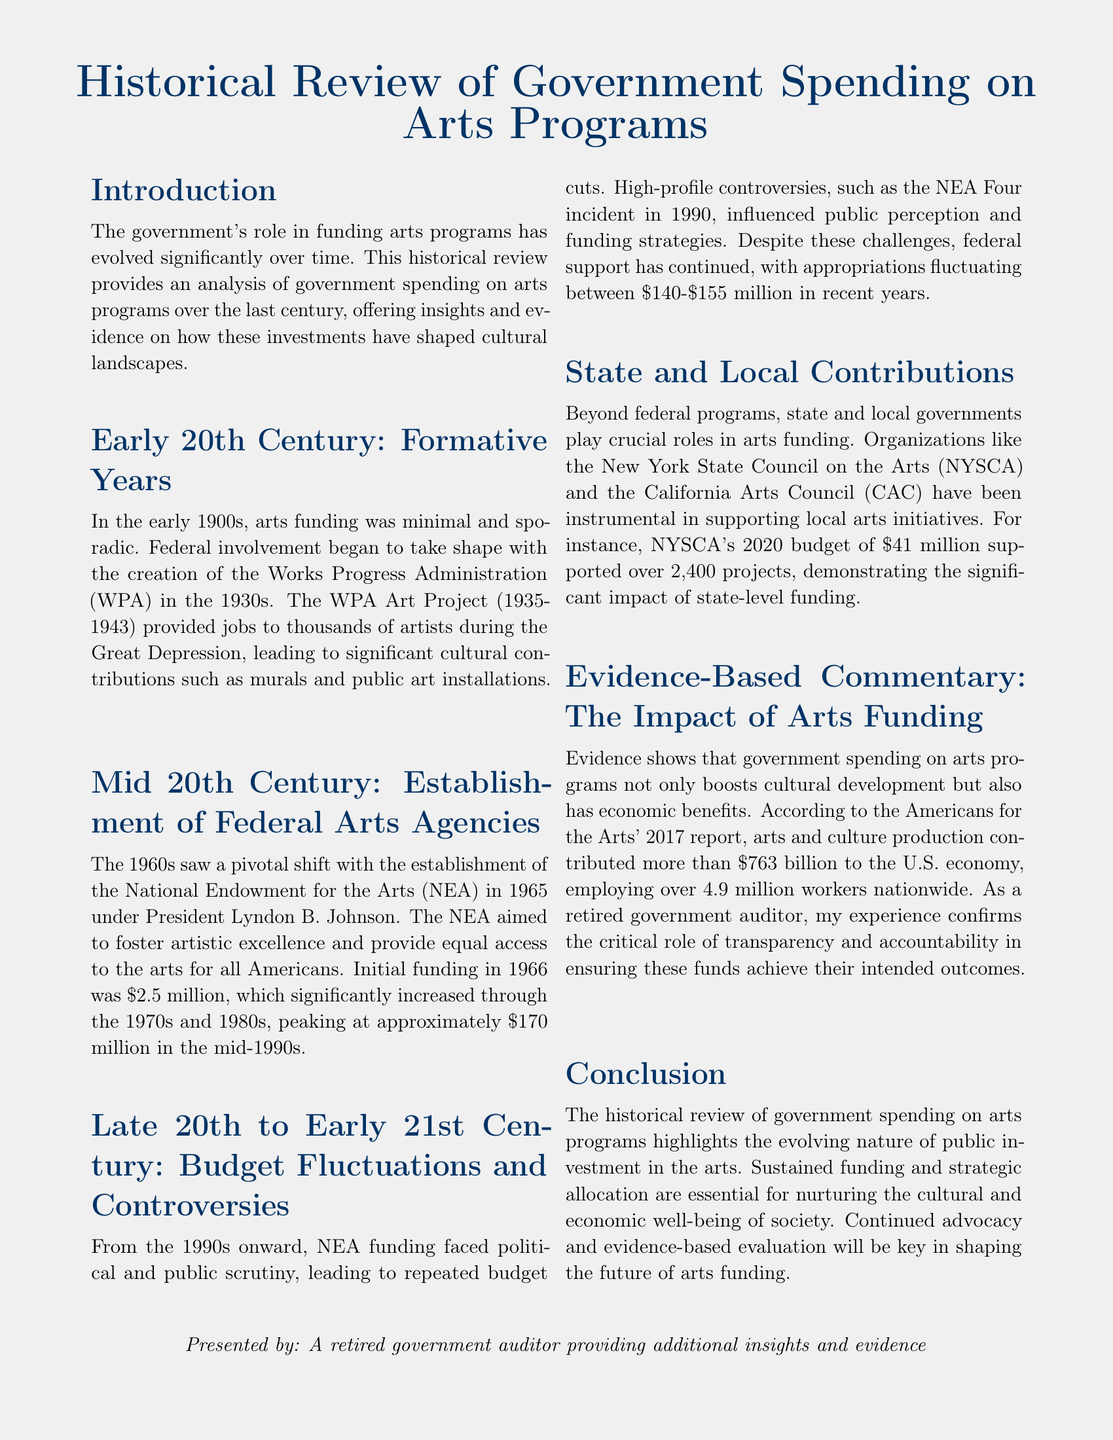What was the initial funding for the NEA in 1966? The initial funding for the NEA in 1966 was $2.5 million.
Answer: $2.5 million What was the peak funding amount for the NEA in the mid-1990s? The NEA's funding peaked at approximately $170 million in the mid-1990s.
Answer: $170 million Which federal program provided jobs to artists during the Great Depression? The federal program that provided jobs to artists during the Great Depression was the Works Progress Administration (WPA).
Answer: Works Progress Administration (WPA) What was NYSCA's budget in 2020? NYSCA's budget in 2020 was $41 million.
Answer: $41 million What was the economic contribution of arts and culture production in 2017 according to the report? According to the report, arts and culture production contributed more than $763 billion to the U.S. economy in 2017.
Answer: $763 billion What was the range of NEA appropriations in recent years mentioned in the document? The NEA appropriations in recent years fluctuated between $140 million and $155 million.
Answer: $140-$155 million What pivotal arts initiative was established under President Lyndon B. Johnson? The pivotal arts initiative established under President Lyndon B. Johnson was the National Endowment for the Arts (NEA).
Answer: National Endowment for the Arts (NEA) What is a key factor in ensuring that arts funding achieves its intended outcomes, according to the commentary? A key factor in ensuring that arts funding achieves its intended outcomes is transparency and accountability.
Answer: Transparency and accountability What role do state and local governments play in arts funding? State and local governments play crucial roles in arts funding.
Answer: Crucial roles 